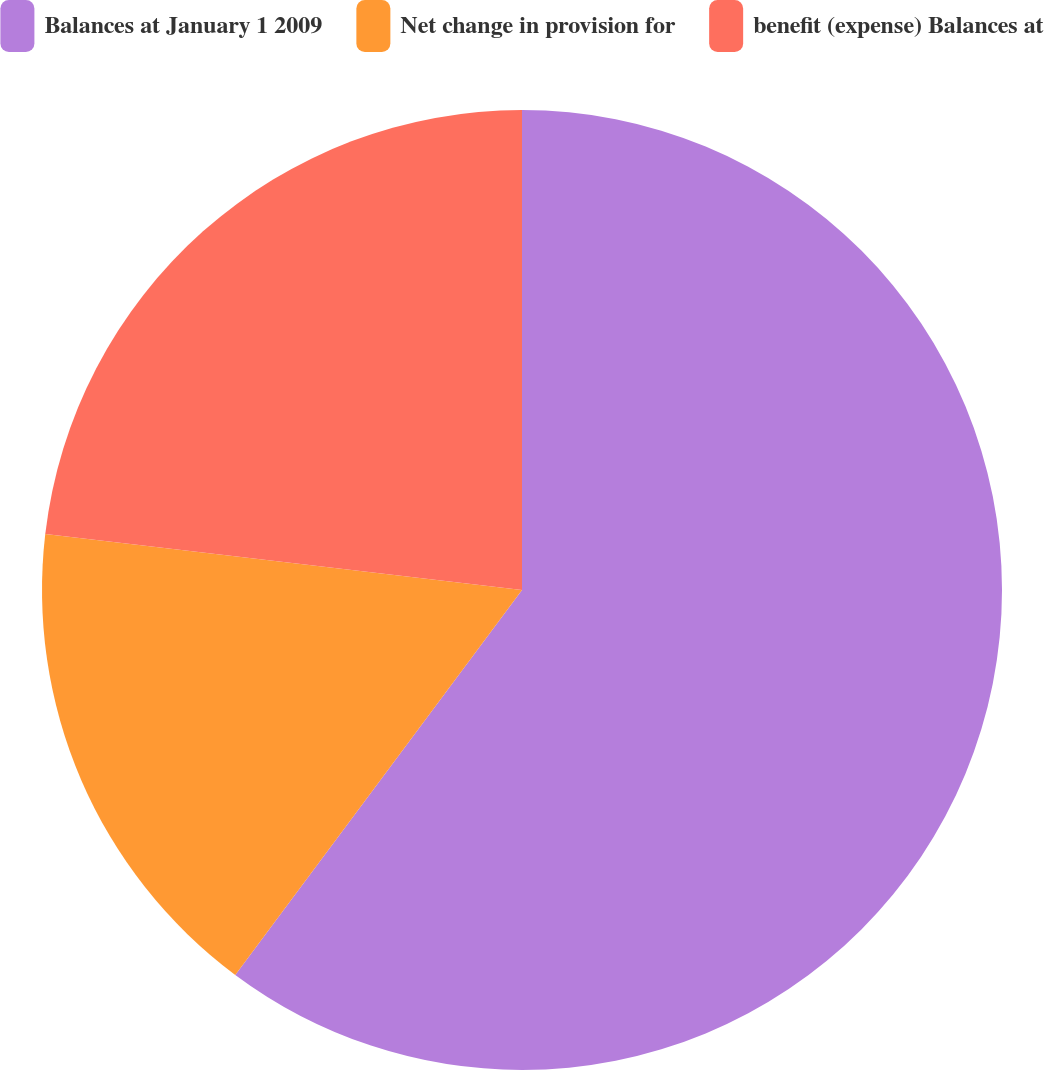Convert chart. <chart><loc_0><loc_0><loc_500><loc_500><pie_chart><fcel>Balances at January 1 2009<fcel>Net change in provision for<fcel>benefit (expense) Balances at<nl><fcel>60.19%<fcel>16.67%<fcel>23.14%<nl></chart> 